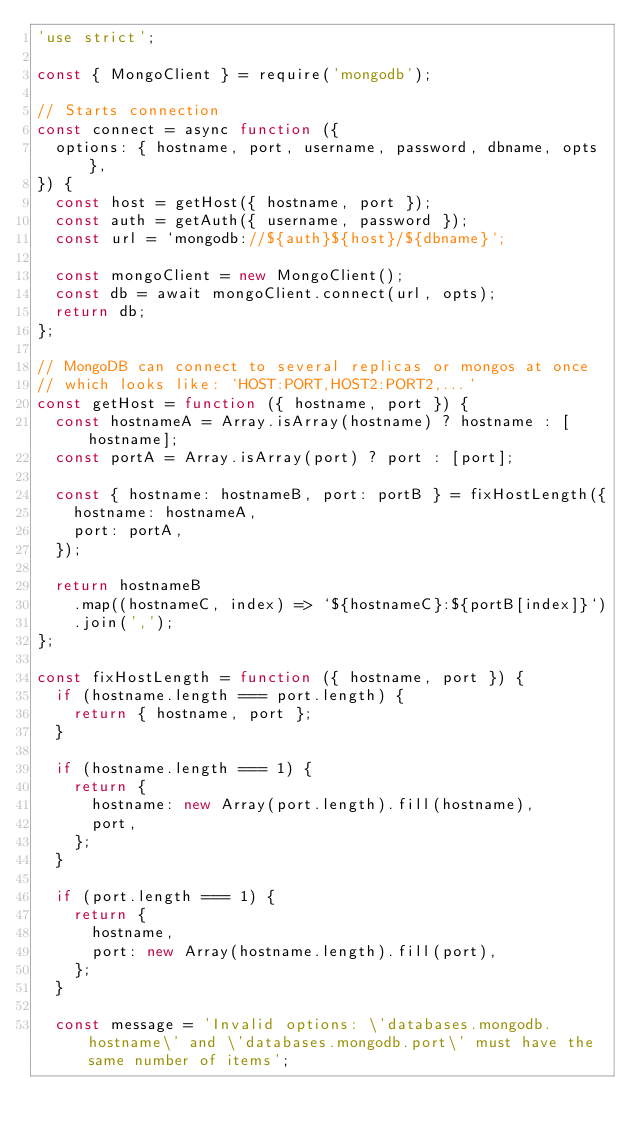Convert code to text. <code><loc_0><loc_0><loc_500><loc_500><_JavaScript_>'use strict';

const { MongoClient } = require('mongodb');

// Starts connection
const connect = async function ({
  options: { hostname, port, username, password, dbname, opts },
}) {
  const host = getHost({ hostname, port });
  const auth = getAuth({ username, password });
  const url = `mongodb://${auth}${host}/${dbname}`;

  const mongoClient = new MongoClient();
  const db = await mongoClient.connect(url, opts);
  return db;
};

// MongoDB can connect to several replicas or mongos at once
// which looks like: `HOST:PORT,HOST2:PORT2,...`
const getHost = function ({ hostname, port }) {
  const hostnameA = Array.isArray(hostname) ? hostname : [hostname];
  const portA = Array.isArray(port) ? port : [port];

  const { hostname: hostnameB, port: portB } = fixHostLength({
    hostname: hostnameA,
    port: portA,
  });

  return hostnameB
    .map((hostnameC, index) => `${hostnameC}:${portB[index]}`)
    .join(',');
};

const fixHostLength = function ({ hostname, port }) {
  if (hostname.length === port.length) {
    return { hostname, port };
  }

  if (hostname.length === 1) {
    return {
      hostname: new Array(port.length).fill(hostname),
      port,
    };
  }

  if (port.length === 1) {
    return {
      hostname,
      port: new Array(hostname.length).fill(port),
    };
  }

  const message = 'Invalid options: \'databases.mongodb.hostname\' and \'databases.mongodb.port\' must have the same number of items';</code> 